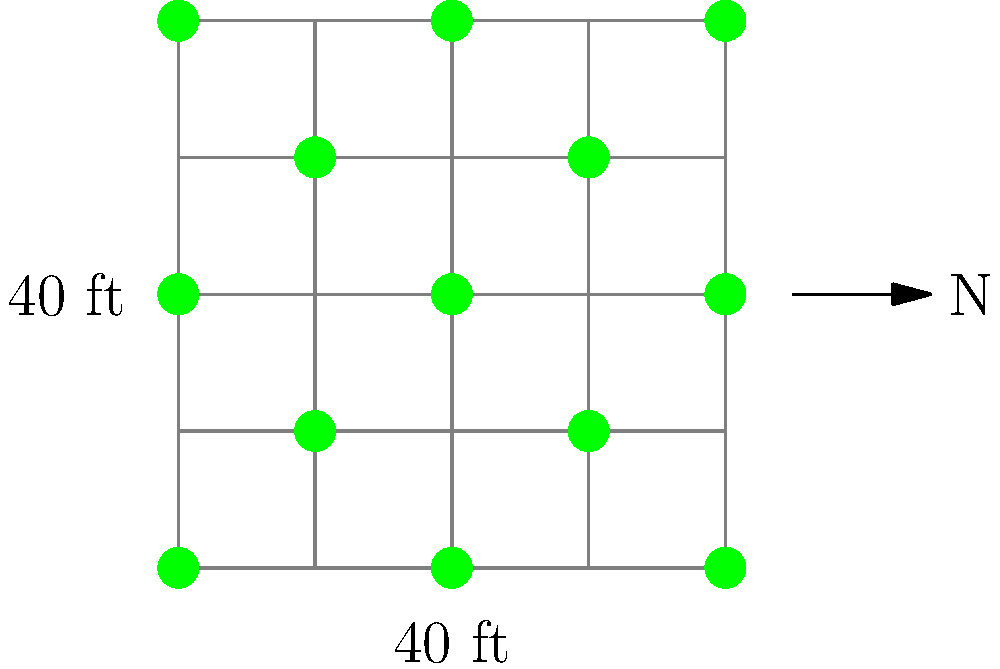In the diagram above, pecan trees are planted in a diagonal pattern within a square grid. If each grid square represents 40 feet by 40 feet, what is the spacing between adjacent pecan trees in this layout? Round your answer to the nearest foot. To find the spacing between adjacent pecan trees, we need to follow these steps:

1. Recognize that the trees are planted diagonally, forming a pattern where each tree is at the corner of a square.

2. The square formed by four adjacent trees has sides of 40 feet (given in the diagram).

3. The diagonal of this square represents the spacing between trees.

4. To calculate the diagonal of a square, we use the Pythagorean theorem:
   $$ diagonal^2 = side^2 + side^2 $$
   $$ diagonal^2 = 40^2 + 40^2 $$
   $$ diagonal^2 = 1600 + 1600 = 3200 $$

5. Take the square root of both sides:
   $$ diagonal = \sqrt{3200} \approx 56.57 $$

6. Rounding to the nearest foot:
   56.57 rounds to 57 feet

Therefore, the spacing between adjacent pecan trees in this layout is approximately 57 feet.
Answer: 57 feet 